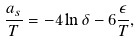<formula> <loc_0><loc_0><loc_500><loc_500>\frac { a _ { s } } { T } = - 4 \ln \delta - 6 \frac { \epsilon } { T } ,</formula> 